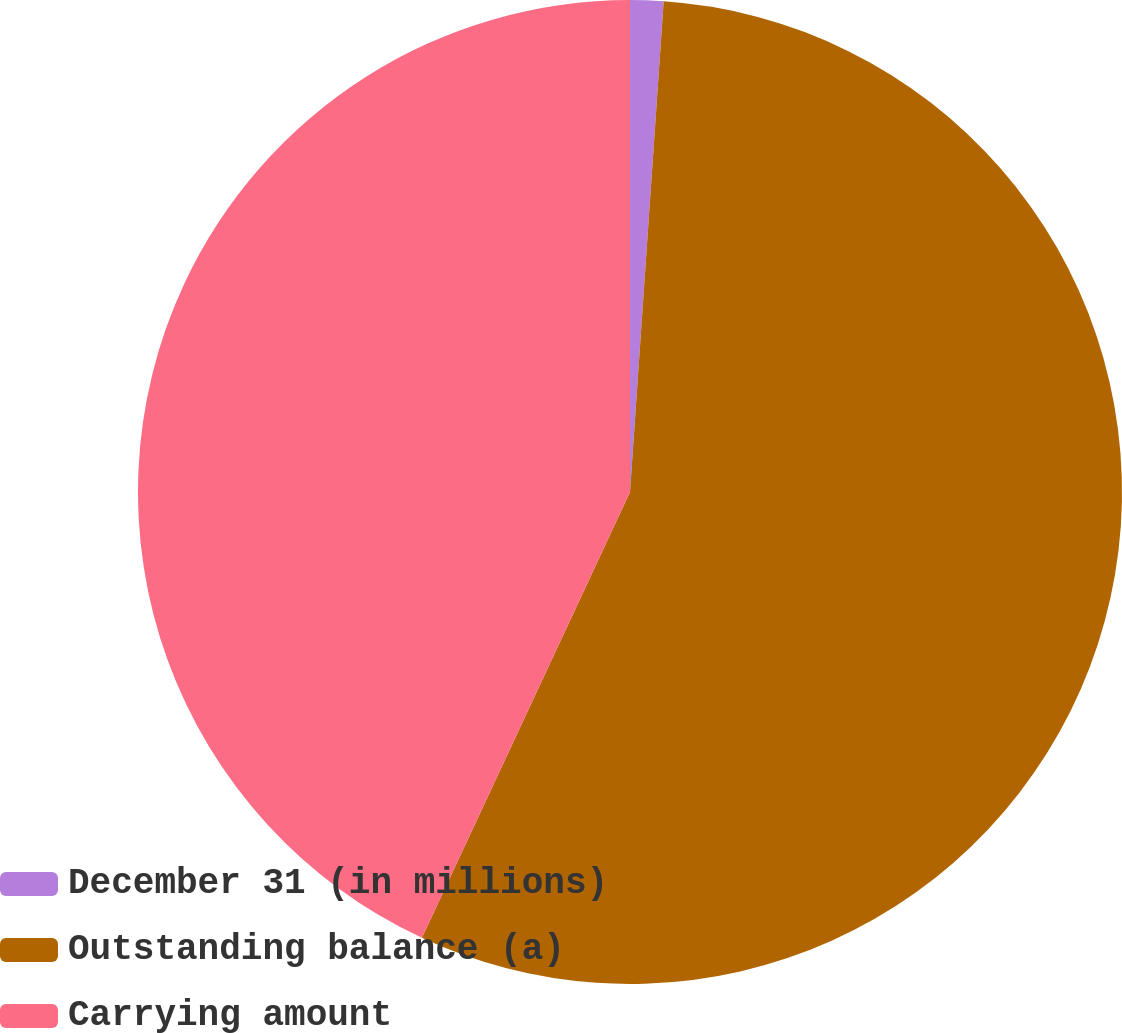Convert chart. <chart><loc_0><loc_0><loc_500><loc_500><pie_chart><fcel>December 31 (in millions)<fcel>Outstanding balance (a)<fcel>Carrying amount<nl><fcel>1.09%<fcel>55.86%<fcel>43.05%<nl></chart> 